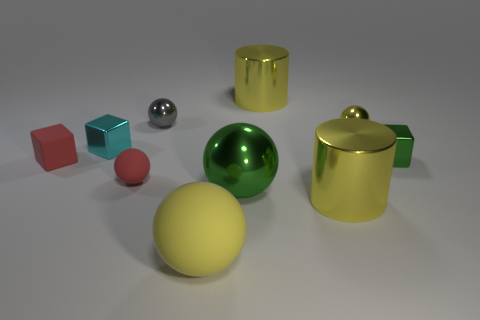How many metal objects are blue balls or tiny balls?
Offer a terse response. 2. What is the color of the thing to the left of the cyan cube that is in front of the tiny metal sphere in front of the gray metal sphere?
Offer a very short reply. Red. How many other things are made of the same material as the large green thing?
Provide a short and direct response. 6. There is a small red matte object left of the tiny cyan shiny object; is it the same shape as the cyan metallic object?
Provide a short and direct response. Yes. How many big objects are either gray metal things or yellow shiny things?
Your answer should be compact. 2. Is the number of yellow metallic balls to the left of the large green metallic ball the same as the number of big yellow spheres that are behind the green cube?
Give a very brief answer. Yes. What number of other objects are there of the same color as the tiny rubber sphere?
Your answer should be compact. 1. Is the color of the small matte ball the same as the small rubber block on the left side of the gray object?
Make the answer very short. Yes. What number of red objects are either metal cylinders or blocks?
Offer a terse response. 1. Are there the same number of small green metal things that are behind the tiny gray metallic thing and small purple objects?
Your answer should be very brief. Yes. 